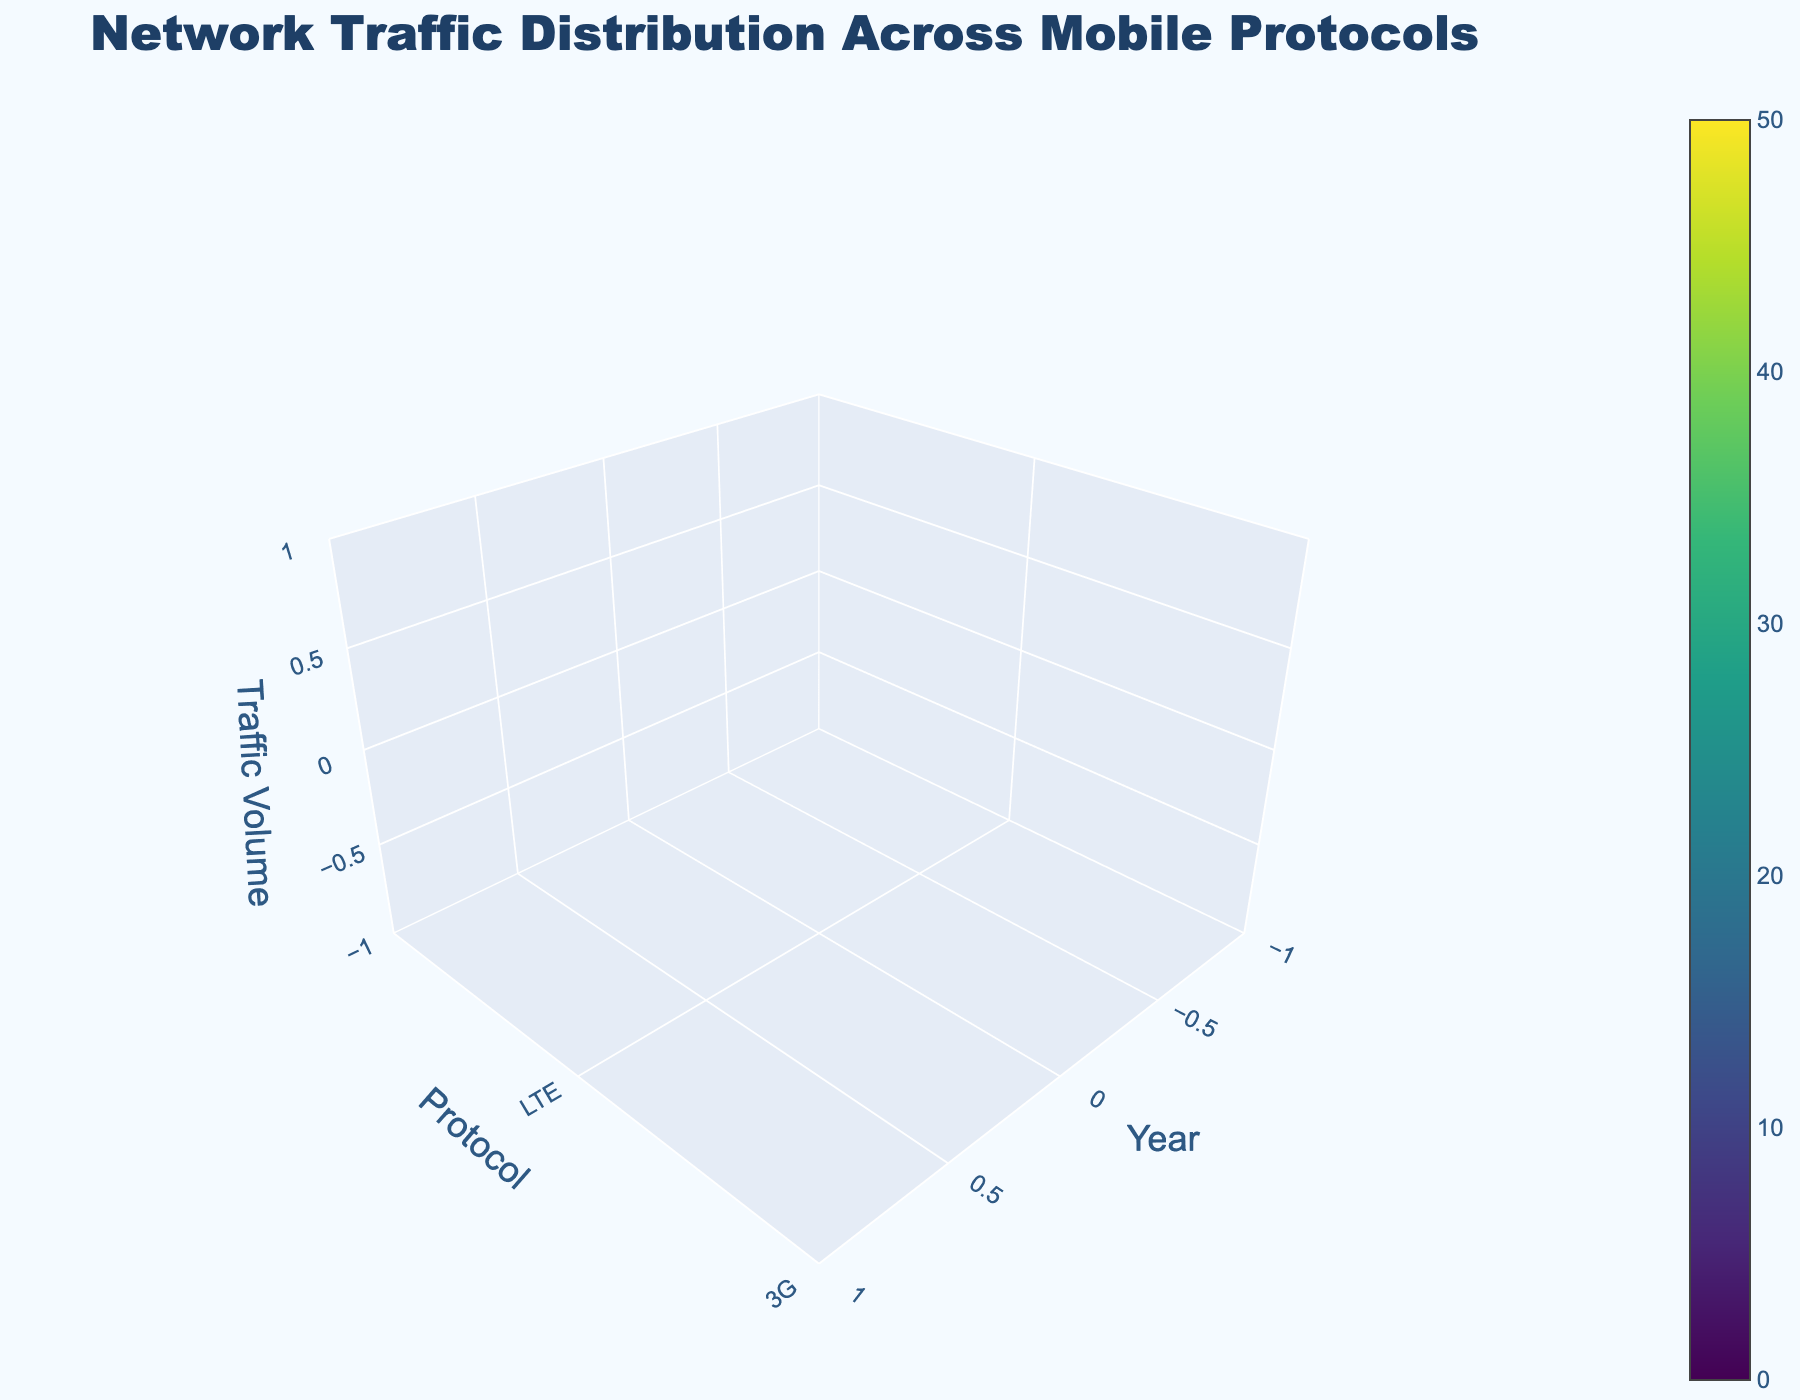What is the title of the figure? The title is usually displayed prominently above the plot and describes the main theme or purpose of the figure. In this case, the title is located at the top of the plot and is easy to identify.
Answer: Network Traffic Distribution Across Mobile Protocols Which mobile protocol had the highest traffic volume in the year 2022? To find this, locate the year 2022 on the x-axis and then look at the z-axis values corresponding to each protocol (LTE, 3G, 2G, 5G). The highest z-axis value indicates the highest traffic volume.
Answer: 5G How has the traffic volume for the LTE protocol changed from 2018 to 2022? To answer this, focus on the z-axis values for the LTE protocol over the years 2018 to 2022. Note the decrease or increase in the values year by year.
Answer: Decreased What is the overall trend for traffic volume in 2G protocol from 2018 to 2022? Look at the z-axis values for the 2G protocol across the years 2018 to 2022. Analyze whether the values show an increasing, decreasing, or stable trend over these years.
Answer: Decreasing In which year did 5G first appear, and what was its traffic volume? Check the z-axis values for the 5G protocol across the years. The first non-zero value indicates the first appearance year of the 5G protocol.
Answer: 2019, 5 Are there any years where the traffic volume for a protocol remained constant? Examine the z-axis values for each protocol year by year. If the values for a protocol don't change from one year to the next, that's a constant volume. In this plot, 5G had the same traffic volume in 2019 and 2020.
Answer: Yes, for 5G in 2019 and 2020 Which year had the lowest traffic volume for the 3G protocol, and what was the volume? Find the z-axis values for the 3G protocol over the years 2018 to 2022. Identify the year with the smallest value.
Answer: 2022, 8 What is the total traffic volume for the year 2021 across all protocols? Sum the z-axis values of all protocols (LTE, 3G, 2G, 5G) for the year 2021.
Answer: 90 Compare the traffic volume of LTE between 2018 and 2019. Which year had a higher volume? Find the z-axis values for the LTE protocol for both years, 2018 and 2019. Compare the values directly.
Answer: 2019 What is the average traffic volume for the 5G protocol from 2019 to 2022? Sum the z-axis values of the 5G protocol from 2019 to 2022 and divide by the number of years (4 years). Sum is 5 + 15 + 30 + 45 = 95, so the average is 95/4 = 23.75.
Answer: 23.75 